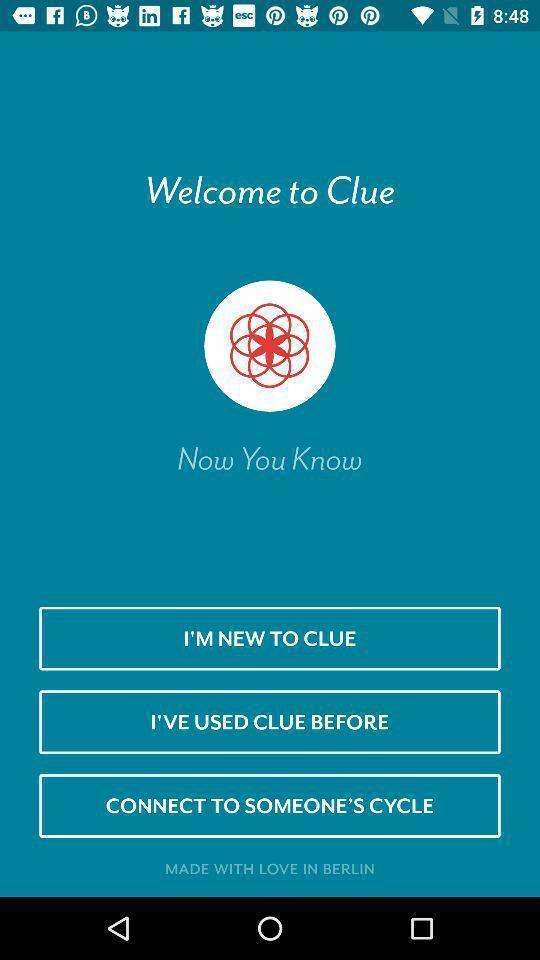Describe this image in words. Welcome page of clue of the app. 